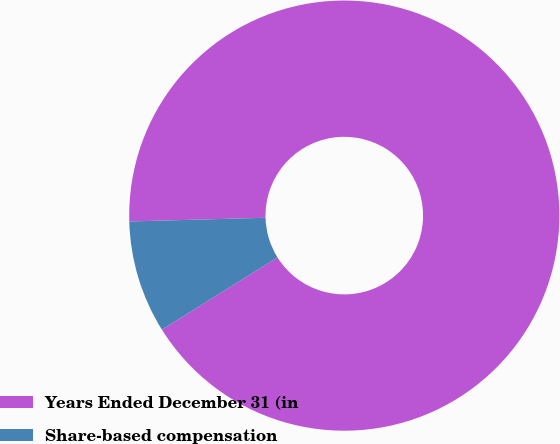Convert chart to OTSL. <chart><loc_0><loc_0><loc_500><loc_500><pie_chart><fcel>Years Ended December 31 (in<fcel>Share-based compensation<nl><fcel>91.54%<fcel>8.46%<nl></chart> 